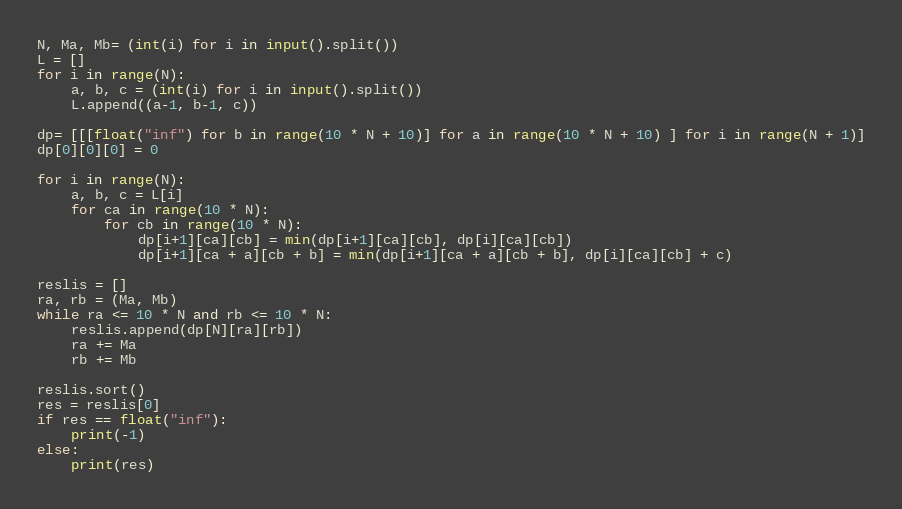Convert code to text. <code><loc_0><loc_0><loc_500><loc_500><_Python_>N, Ma, Mb= (int(i) for i in input().split())
L = []
for i in range(N):
    a, b, c = (int(i) for i in input().split())
    L.append((a-1, b-1, c))

dp= [[[float("inf") for b in range(10 * N + 10)] for a in range(10 * N + 10) ] for i in range(N + 1)]
dp[0][0][0] = 0

for i in range(N):
    a, b, c = L[i]
    for ca in range(10 * N):
        for cb in range(10 * N):
            dp[i+1][ca][cb] = min(dp[i+1][ca][cb], dp[i][ca][cb])
            dp[i+1][ca + a][cb + b] = min(dp[i+1][ca + a][cb + b], dp[i][ca][cb] + c)

reslis = []
ra, rb = (Ma, Mb)
while ra <= 10 * N and rb <= 10 * N:
    reslis.append(dp[N][ra][rb])
    ra += Ma
    rb += Mb

reslis.sort()
res = reslis[0]
if res == float("inf"):
    print(-1)
else:
    print(res)
</code> 